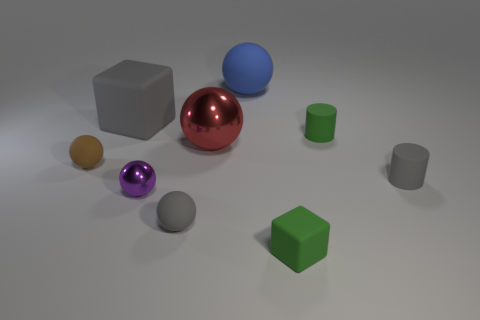Is there a tiny matte thing of the same color as the small block?
Ensure brevity in your answer.  Yes. There is another large thing that is the same shape as the red object; what is its color?
Provide a succinct answer. Blue. There is a gray object that is behind the tiny ball to the left of the big block; are there any small rubber cylinders that are on the right side of it?
Your answer should be compact. Yes. What is the color of the ball that is the same material as the small purple object?
Make the answer very short. Red. What size is the rubber ball that is both to the left of the blue ball and right of the brown matte sphere?
Your answer should be very brief. Small. Is the number of tiny gray rubber things that are behind the big blue ball less than the number of purple metal spheres that are behind the big shiny ball?
Make the answer very short. No. Are the small gray thing that is to the right of the large red ball and the tiny cylinder behind the big metallic object made of the same material?
Your response must be concise. Yes. What material is the cylinder that is the same color as the tiny matte block?
Make the answer very short. Rubber. There is a rubber object that is to the right of the big blue rubber sphere and behind the red ball; what is its shape?
Your answer should be compact. Cylinder. There is a tiny green object that is to the right of the green object that is in front of the large metal sphere; what is its material?
Your answer should be compact. Rubber. 